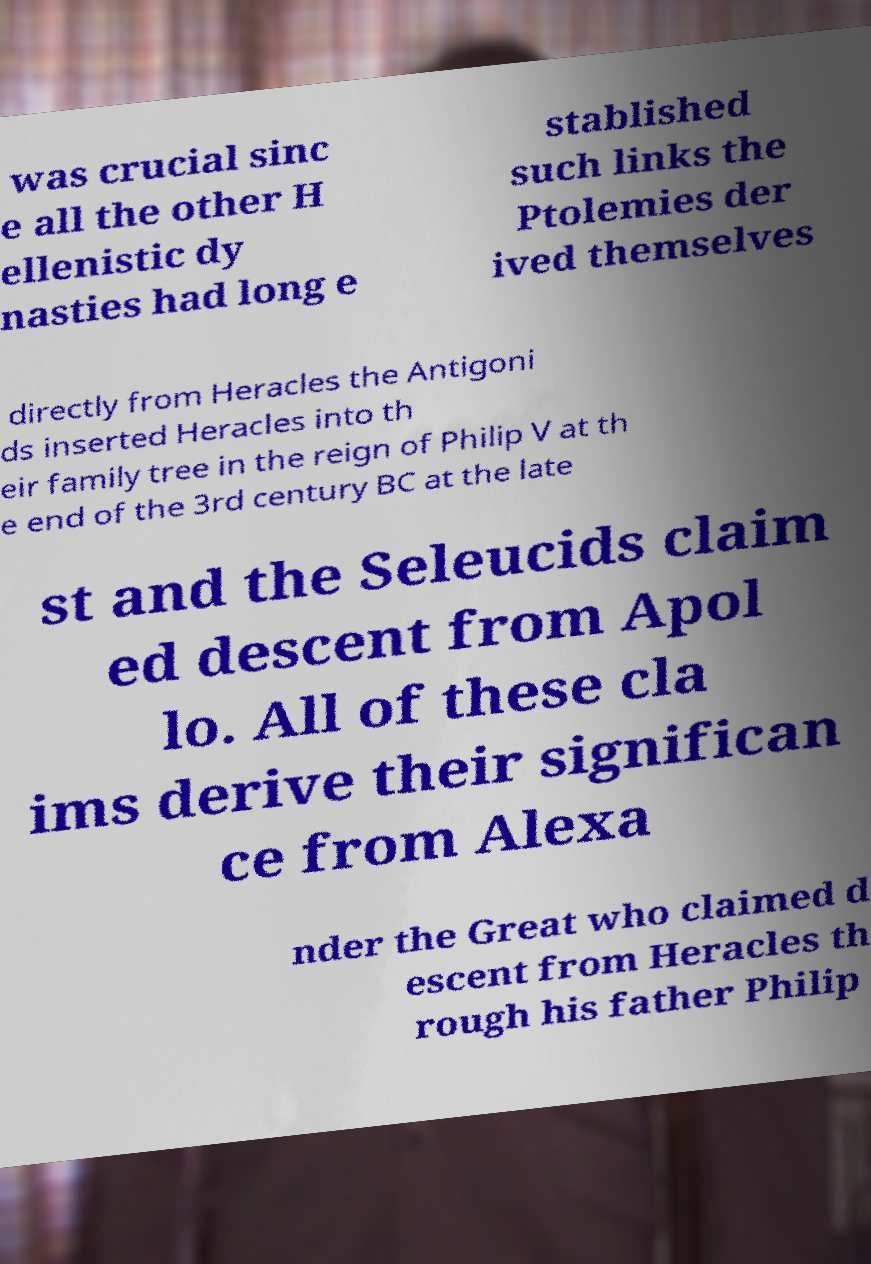For documentation purposes, I need the text within this image transcribed. Could you provide that? was crucial sinc e all the other H ellenistic dy nasties had long e stablished such links the Ptolemies der ived themselves directly from Heracles the Antigoni ds inserted Heracles into th eir family tree in the reign of Philip V at th e end of the 3rd century BC at the late st and the Seleucids claim ed descent from Apol lo. All of these cla ims derive their significan ce from Alexa nder the Great who claimed d escent from Heracles th rough his father Philip 